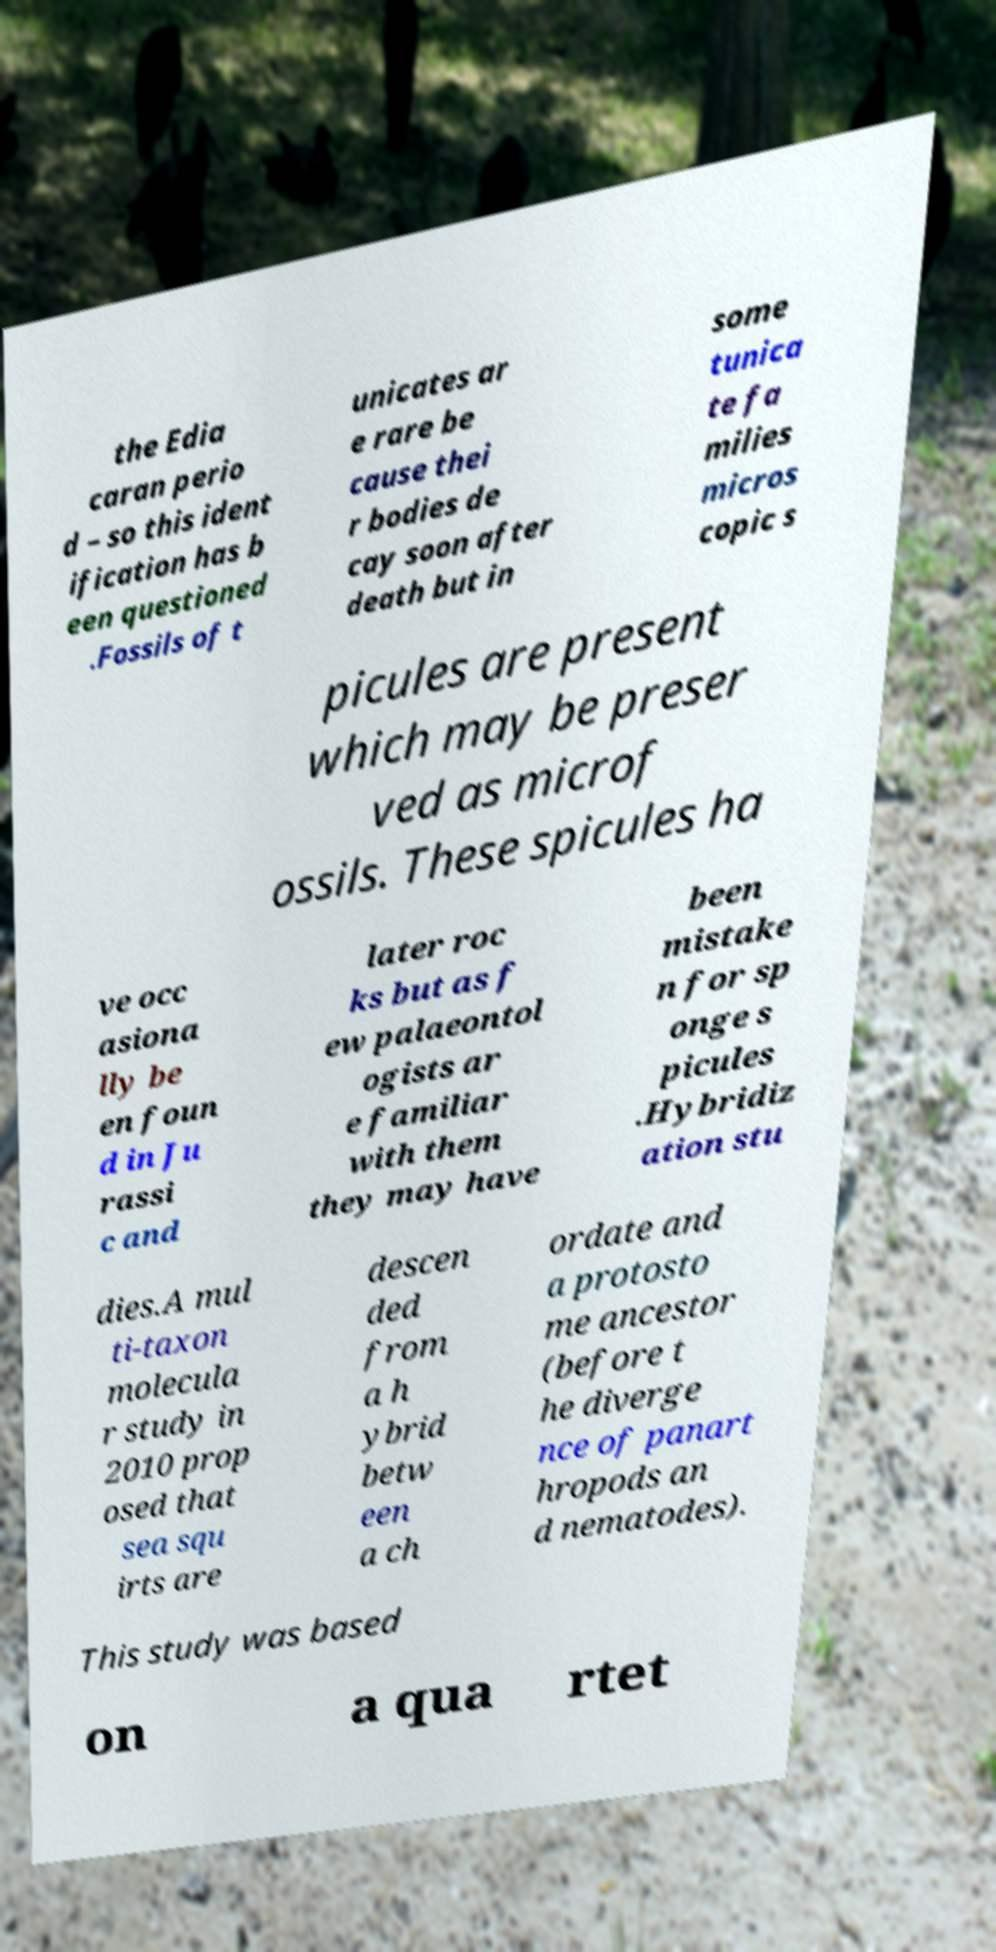Could you assist in decoding the text presented in this image and type it out clearly? the Edia caran perio d – so this ident ification has b een questioned .Fossils of t unicates ar e rare be cause thei r bodies de cay soon after death but in some tunica te fa milies micros copic s picules are present which may be preser ved as microf ossils. These spicules ha ve occ asiona lly be en foun d in Ju rassi c and later roc ks but as f ew palaeontol ogists ar e familiar with them they may have been mistake n for sp onge s picules .Hybridiz ation stu dies.A mul ti-taxon molecula r study in 2010 prop osed that sea squ irts are descen ded from a h ybrid betw een a ch ordate and a protosto me ancestor (before t he diverge nce of panart hropods an d nematodes). This study was based on a qua rtet 